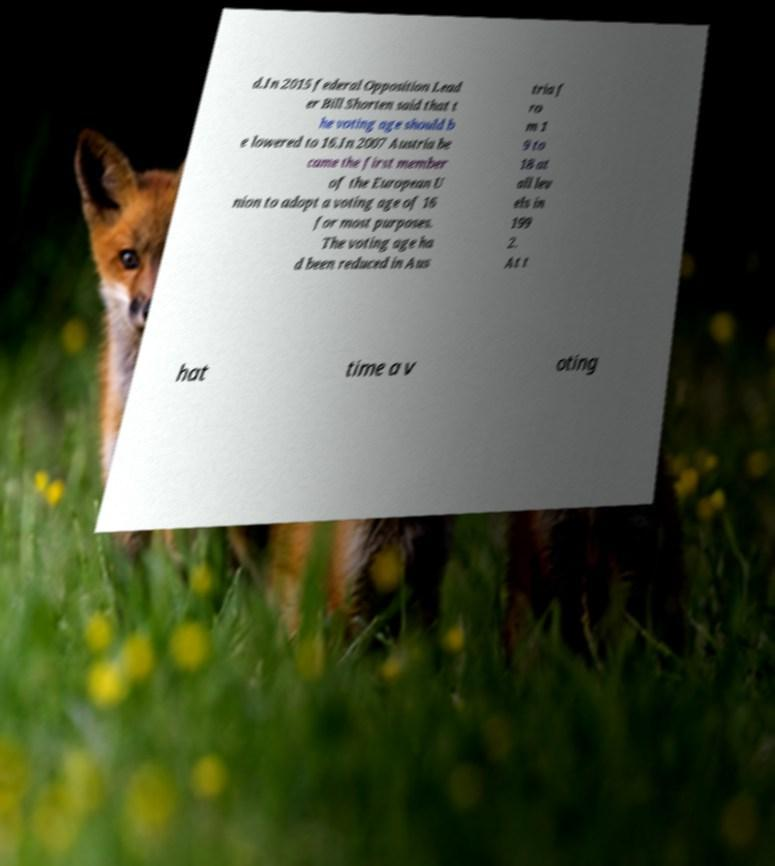Please read and relay the text visible in this image. What does it say? d.In 2015 federal Opposition Lead er Bill Shorten said that t he voting age should b e lowered to 16.In 2007 Austria be came the first member of the European U nion to adopt a voting age of 16 for most purposes. The voting age ha d been reduced in Aus tria f ro m 1 9 to 18 at all lev els in 199 2. At t hat time a v oting 